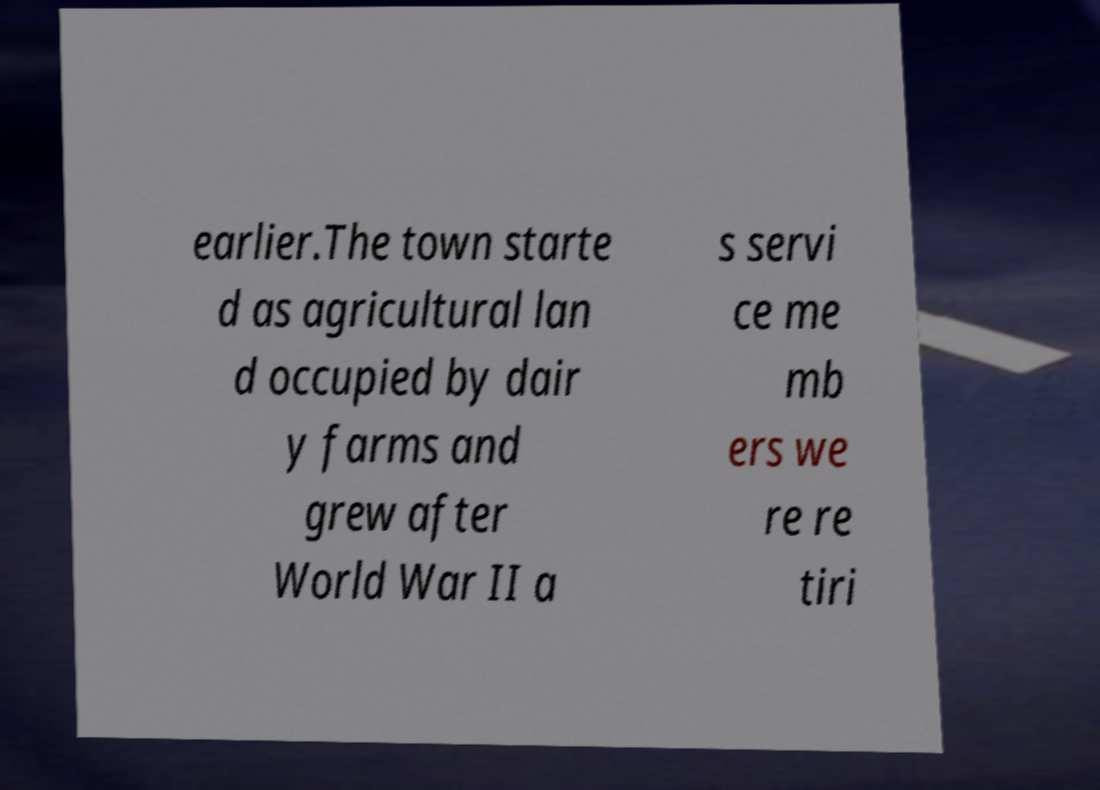Could you assist in decoding the text presented in this image and type it out clearly? earlier.The town starte d as agricultural lan d occupied by dair y farms and grew after World War II a s servi ce me mb ers we re re tiri 